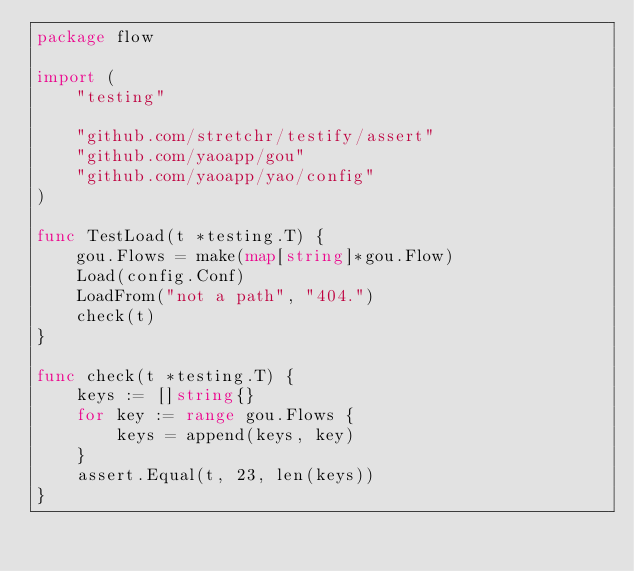Convert code to text. <code><loc_0><loc_0><loc_500><loc_500><_Go_>package flow

import (
	"testing"

	"github.com/stretchr/testify/assert"
	"github.com/yaoapp/gou"
	"github.com/yaoapp/yao/config"
)

func TestLoad(t *testing.T) {
	gou.Flows = make(map[string]*gou.Flow)
	Load(config.Conf)
	LoadFrom("not a path", "404.")
	check(t)
}

func check(t *testing.T) {
	keys := []string{}
	for key := range gou.Flows {
		keys = append(keys, key)
	}
	assert.Equal(t, 23, len(keys))
}
</code> 